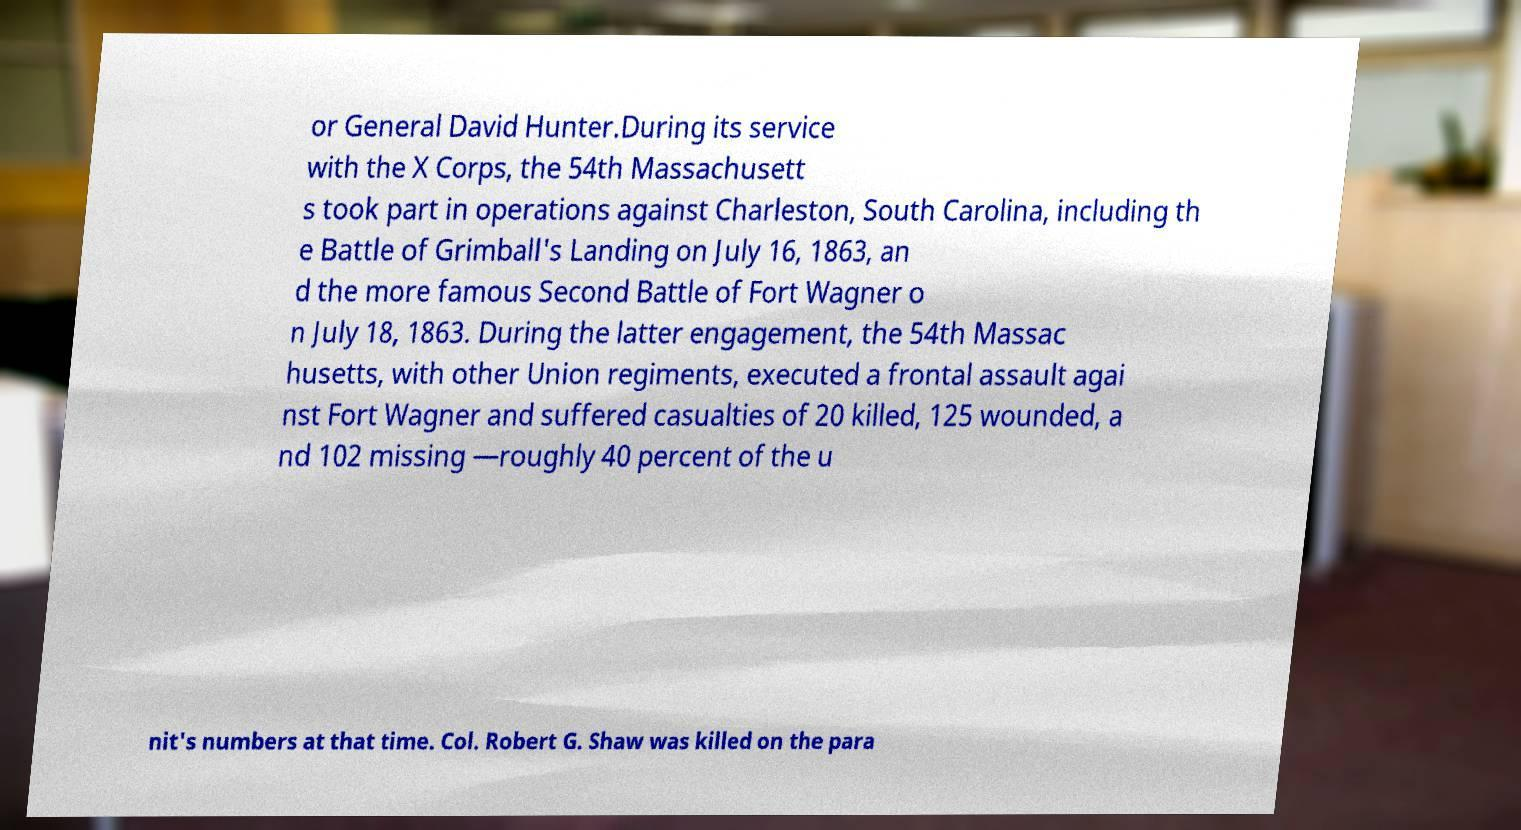There's text embedded in this image that I need extracted. Can you transcribe it verbatim? or General David Hunter.During its service with the X Corps, the 54th Massachusett s took part in operations against Charleston, South Carolina, including th e Battle of Grimball's Landing on July 16, 1863, an d the more famous Second Battle of Fort Wagner o n July 18, 1863. During the latter engagement, the 54th Massac husetts, with other Union regiments, executed a frontal assault agai nst Fort Wagner and suffered casualties of 20 killed, 125 wounded, a nd 102 missing —roughly 40 percent of the u nit's numbers at that time. Col. Robert G. Shaw was killed on the para 